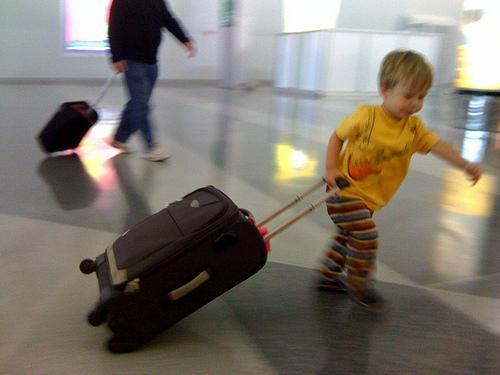How many suitcases are in the picture?
Give a very brief answer. 2. How many people are in the photo?
Give a very brief answer. 2. 